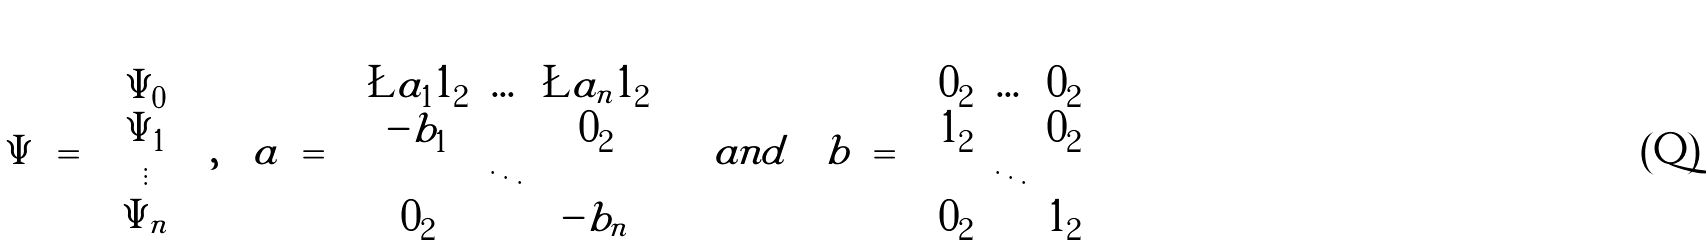<formula> <loc_0><loc_0><loc_500><loc_500>\Psi \ = \ \begin{pmatrix} \Psi _ { 0 } \\ \Psi _ { 1 } \\ \vdots \\ \Psi _ { n } \end{pmatrix} \ , \quad a \ = \ \begin{pmatrix} \L a _ { 1 } { 1 } _ { 2 } & \dots & \L a _ { n } { 1 } _ { 2 } \\ - b _ { 1 } & & { 0 } _ { 2 } \\ & \ddots & \\ { 0 } _ { 2 } & & - b _ { n } \end{pmatrix} \quad a n d \quad b \ = \ \begin{pmatrix} { 0 } _ { 2 } & \dots & { 0 } _ { 2 } \\ { 1 } _ { 2 } & & { 0 } _ { 2 } \\ & \ddots & \\ { 0 } _ { 2 } & & { 1 } _ { 2 } \end{pmatrix}</formula> 